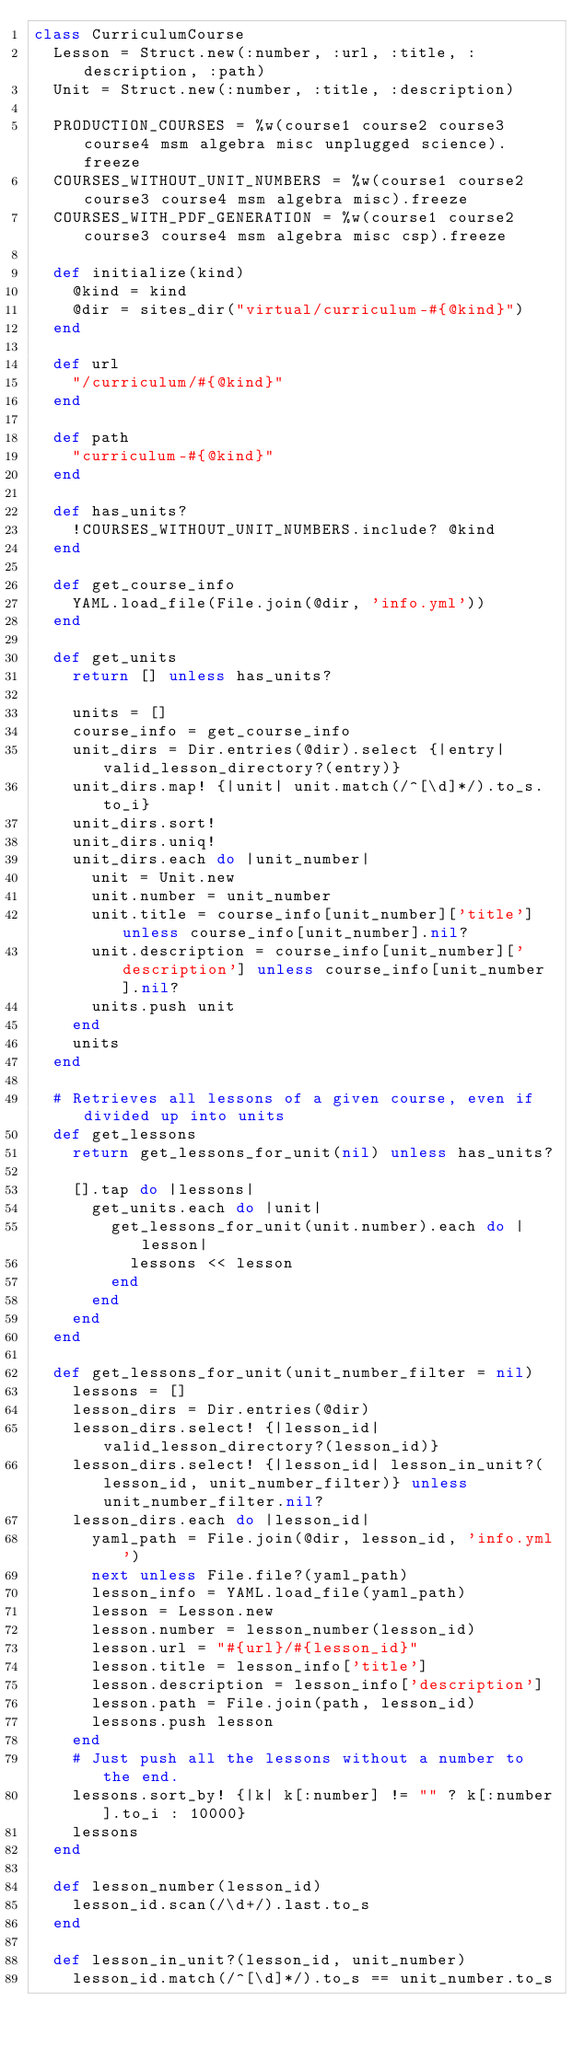Convert code to text. <code><loc_0><loc_0><loc_500><loc_500><_Ruby_>class CurriculumCourse
  Lesson = Struct.new(:number, :url, :title, :description, :path)
  Unit = Struct.new(:number, :title, :description)

  PRODUCTION_COURSES = %w(course1 course2 course3 course4 msm algebra misc unplugged science).freeze
  COURSES_WITHOUT_UNIT_NUMBERS = %w(course1 course2 course3 course4 msm algebra misc).freeze
  COURSES_WITH_PDF_GENERATION = %w(course1 course2 course3 course4 msm algebra misc csp).freeze

  def initialize(kind)
    @kind = kind
    @dir = sites_dir("virtual/curriculum-#{@kind}")
  end

  def url
    "/curriculum/#{@kind}"
  end

  def path
    "curriculum-#{@kind}"
  end

  def has_units?
    !COURSES_WITHOUT_UNIT_NUMBERS.include? @kind
  end

  def get_course_info
    YAML.load_file(File.join(@dir, 'info.yml'))
  end

  def get_units
    return [] unless has_units?

    units = []
    course_info = get_course_info
    unit_dirs = Dir.entries(@dir).select {|entry| valid_lesson_directory?(entry)}
    unit_dirs.map! {|unit| unit.match(/^[\d]*/).to_s.to_i}
    unit_dirs.sort!
    unit_dirs.uniq!
    unit_dirs.each do |unit_number|
      unit = Unit.new
      unit.number = unit_number
      unit.title = course_info[unit_number]['title'] unless course_info[unit_number].nil?
      unit.description = course_info[unit_number]['description'] unless course_info[unit_number].nil?
      units.push unit
    end
    units
  end

  # Retrieves all lessons of a given course, even if divided up into units
  def get_lessons
    return get_lessons_for_unit(nil) unless has_units?

    [].tap do |lessons|
      get_units.each do |unit|
        get_lessons_for_unit(unit.number).each do |lesson|
          lessons << lesson
        end
      end
    end
  end

  def get_lessons_for_unit(unit_number_filter = nil)
    lessons = []
    lesson_dirs = Dir.entries(@dir)
    lesson_dirs.select! {|lesson_id| valid_lesson_directory?(lesson_id)}
    lesson_dirs.select! {|lesson_id| lesson_in_unit?(lesson_id, unit_number_filter)} unless unit_number_filter.nil?
    lesson_dirs.each do |lesson_id|
      yaml_path = File.join(@dir, lesson_id, 'info.yml')
      next unless File.file?(yaml_path)
      lesson_info = YAML.load_file(yaml_path)
      lesson = Lesson.new
      lesson.number = lesson_number(lesson_id)
      lesson.url = "#{url}/#{lesson_id}"
      lesson.title = lesson_info['title']
      lesson.description = lesson_info['description']
      lesson.path = File.join(path, lesson_id)
      lessons.push lesson
    end
    # Just push all the lessons without a number to the end.
    lessons.sort_by! {|k| k[:number] != "" ? k[:number].to_i : 10000}
    lessons
  end

  def lesson_number(lesson_id)
    lesson_id.scan(/\d+/).last.to_s
  end

  def lesson_in_unit?(lesson_id, unit_number)
    lesson_id.match(/^[\d]*/).to_s == unit_number.to_s</code> 